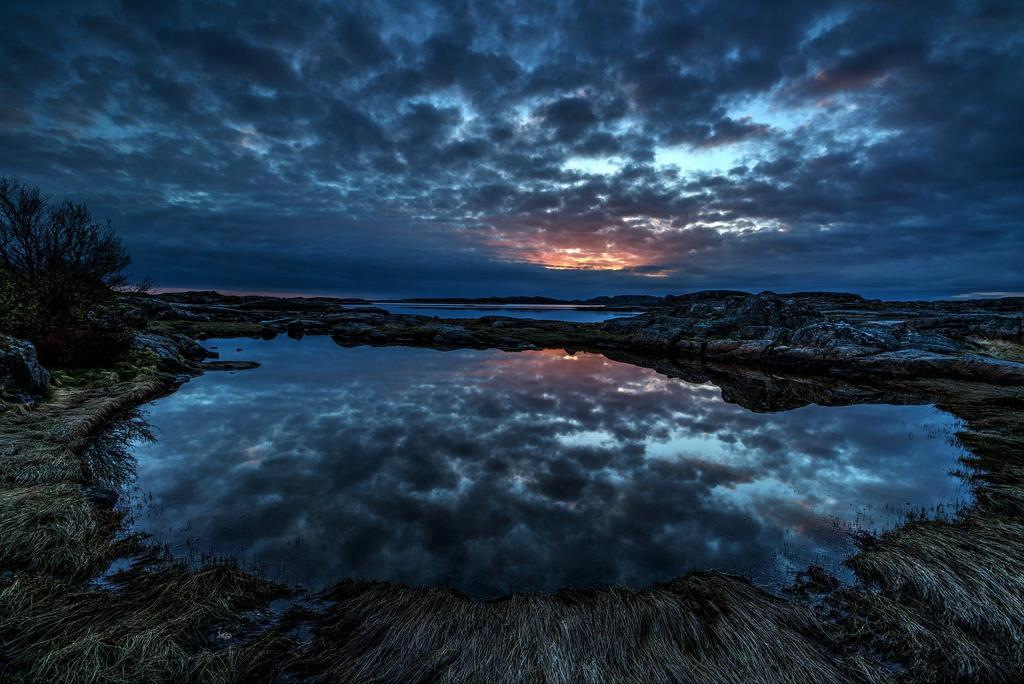What type of vegetation is present in the image? There is grass in the image. What natural element is also visible in the image? There is water in the image. Can you describe any other objects or features in the image? There is a rock in the image. Where is the tree located in the image? There is a tree on the left side of the image. What can be seen in the sky in the background of the image? There are clouds in the sky in the background of the image. What type of paste is being used to create the fish in the image? There are no fish present in the image, and therefore no paste is being used to create them. 